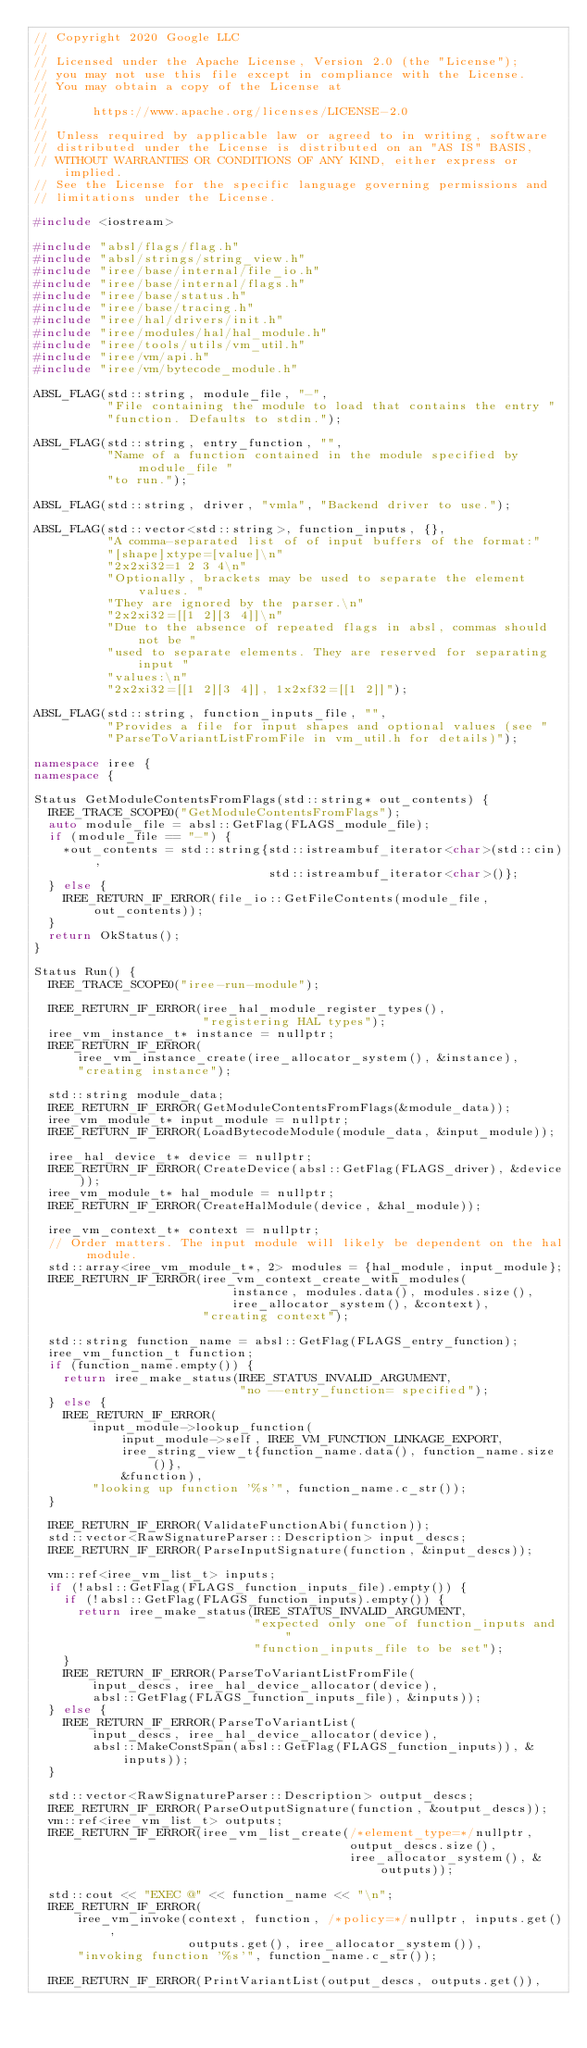<code> <loc_0><loc_0><loc_500><loc_500><_C++_>// Copyright 2020 Google LLC
//
// Licensed under the Apache License, Version 2.0 (the "License");
// you may not use this file except in compliance with the License.
// You may obtain a copy of the License at
//
//      https://www.apache.org/licenses/LICENSE-2.0
//
// Unless required by applicable law or agreed to in writing, software
// distributed under the License is distributed on an "AS IS" BASIS,
// WITHOUT WARRANTIES OR CONDITIONS OF ANY KIND, either express or implied.
// See the License for the specific language governing permissions and
// limitations under the License.

#include <iostream>

#include "absl/flags/flag.h"
#include "absl/strings/string_view.h"
#include "iree/base/internal/file_io.h"
#include "iree/base/internal/flags.h"
#include "iree/base/status.h"
#include "iree/base/tracing.h"
#include "iree/hal/drivers/init.h"
#include "iree/modules/hal/hal_module.h"
#include "iree/tools/utils/vm_util.h"
#include "iree/vm/api.h"
#include "iree/vm/bytecode_module.h"

ABSL_FLAG(std::string, module_file, "-",
          "File containing the module to load that contains the entry "
          "function. Defaults to stdin.");

ABSL_FLAG(std::string, entry_function, "",
          "Name of a function contained in the module specified by module_file "
          "to run.");

ABSL_FLAG(std::string, driver, "vmla", "Backend driver to use.");

ABSL_FLAG(std::vector<std::string>, function_inputs, {},
          "A comma-separated list of of input buffers of the format:"
          "[shape]xtype=[value]\n"
          "2x2xi32=1 2 3 4\n"
          "Optionally, brackets may be used to separate the element values. "
          "They are ignored by the parser.\n"
          "2x2xi32=[[1 2][3 4]]\n"
          "Due to the absence of repeated flags in absl, commas should not be "
          "used to separate elements. They are reserved for separating input "
          "values:\n"
          "2x2xi32=[[1 2][3 4]], 1x2xf32=[[1 2]]");

ABSL_FLAG(std::string, function_inputs_file, "",
          "Provides a file for input shapes and optional values (see "
          "ParseToVariantListFromFile in vm_util.h for details)");

namespace iree {
namespace {

Status GetModuleContentsFromFlags(std::string* out_contents) {
  IREE_TRACE_SCOPE0("GetModuleContentsFromFlags");
  auto module_file = absl::GetFlag(FLAGS_module_file);
  if (module_file == "-") {
    *out_contents = std::string{std::istreambuf_iterator<char>(std::cin),
                                std::istreambuf_iterator<char>()};
  } else {
    IREE_RETURN_IF_ERROR(file_io::GetFileContents(module_file, out_contents));
  }
  return OkStatus();
}

Status Run() {
  IREE_TRACE_SCOPE0("iree-run-module");

  IREE_RETURN_IF_ERROR(iree_hal_module_register_types(),
                       "registering HAL types");
  iree_vm_instance_t* instance = nullptr;
  IREE_RETURN_IF_ERROR(
      iree_vm_instance_create(iree_allocator_system(), &instance),
      "creating instance");

  std::string module_data;
  IREE_RETURN_IF_ERROR(GetModuleContentsFromFlags(&module_data));
  iree_vm_module_t* input_module = nullptr;
  IREE_RETURN_IF_ERROR(LoadBytecodeModule(module_data, &input_module));

  iree_hal_device_t* device = nullptr;
  IREE_RETURN_IF_ERROR(CreateDevice(absl::GetFlag(FLAGS_driver), &device));
  iree_vm_module_t* hal_module = nullptr;
  IREE_RETURN_IF_ERROR(CreateHalModule(device, &hal_module));

  iree_vm_context_t* context = nullptr;
  // Order matters. The input module will likely be dependent on the hal module.
  std::array<iree_vm_module_t*, 2> modules = {hal_module, input_module};
  IREE_RETURN_IF_ERROR(iree_vm_context_create_with_modules(
                           instance, modules.data(), modules.size(),
                           iree_allocator_system(), &context),
                       "creating context");

  std::string function_name = absl::GetFlag(FLAGS_entry_function);
  iree_vm_function_t function;
  if (function_name.empty()) {
    return iree_make_status(IREE_STATUS_INVALID_ARGUMENT,
                            "no --entry_function= specified");
  } else {
    IREE_RETURN_IF_ERROR(
        input_module->lookup_function(
            input_module->self, IREE_VM_FUNCTION_LINKAGE_EXPORT,
            iree_string_view_t{function_name.data(), function_name.size()},
            &function),
        "looking up function '%s'", function_name.c_str());
  }

  IREE_RETURN_IF_ERROR(ValidateFunctionAbi(function));
  std::vector<RawSignatureParser::Description> input_descs;
  IREE_RETURN_IF_ERROR(ParseInputSignature(function, &input_descs));

  vm::ref<iree_vm_list_t> inputs;
  if (!absl::GetFlag(FLAGS_function_inputs_file).empty()) {
    if (!absl::GetFlag(FLAGS_function_inputs).empty()) {
      return iree_make_status(IREE_STATUS_INVALID_ARGUMENT,
                              "expected only one of function_inputs and "
                              "function_inputs_file to be set");
    }
    IREE_RETURN_IF_ERROR(ParseToVariantListFromFile(
        input_descs, iree_hal_device_allocator(device),
        absl::GetFlag(FLAGS_function_inputs_file), &inputs));
  } else {
    IREE_RETURN_IF_ERROR(ParseToVariantList(
        input_descs, iree_hal_device_allocator(device),
        absl::MakeConstSpan(absl::GetFlag(FLAGS_function_inputs)), &inputs));
  }

  std::vector<RawSignatureParser::Description> output_descs;
  IREE_RETURN_IF_ERROR(ParseOutputSignature(function, &output_descs));
  vm::ref<iree_vm_list_t> outputs;
  IREE_RETURN_IF_ERROR(iree_vm_list_create(/*element_type=*/nullptr,
                                           output_descs.size(),
                                           iree_allocator_system(), &outputs));

  std::cout << "EXEC @" << function_name << "\n";
  IREE_RETURN_IF_ERROR(
      iree_vm_invoke(context, function, /*policy=*/nullptr, inputs.get(),
                     outputs.get(), iree_allocator_system()),
      "invoking function '%s'", function_name.c_str());

  IREE_RETURN_IF_ERROR(PrintVariantList(output_descs, outputs.get()),</code> 